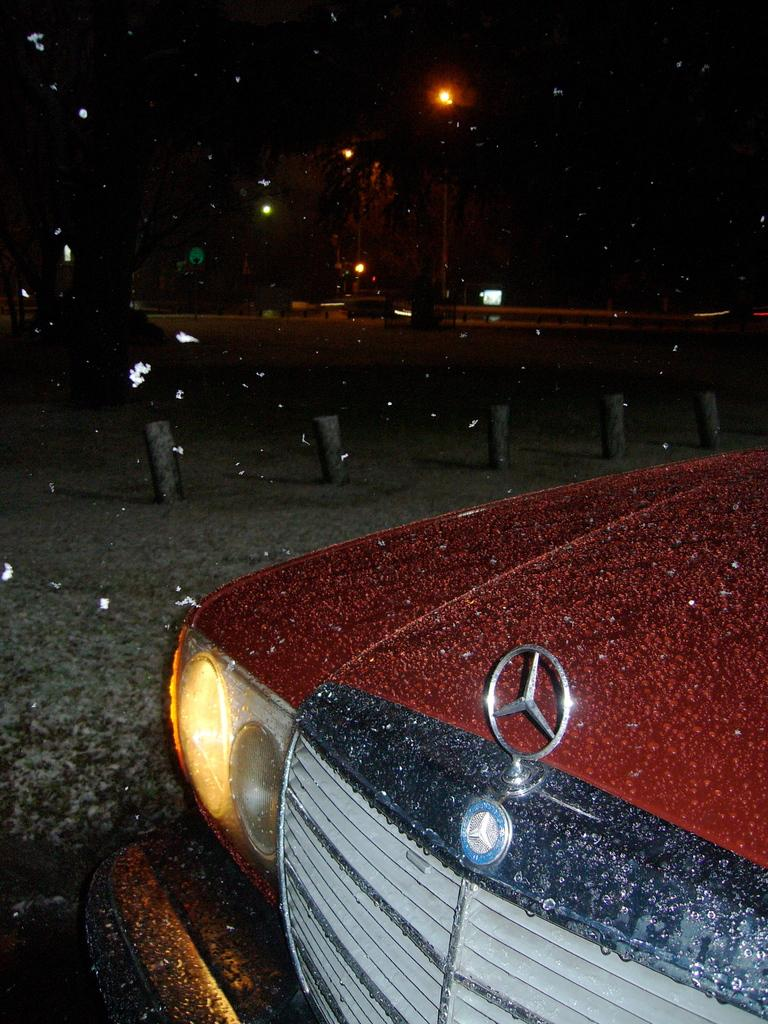What type of vehicle is in the image? There is a red color car in the image. What other objects can be seen in the image besides the car? There are light poles in the image. How would you describe the background of the image? The background of the image is dark in color. What type of trouble is the mother experiencing with the bottle in the image? There is no mother or bottle present in the image, so it is not possible to answer that question. 